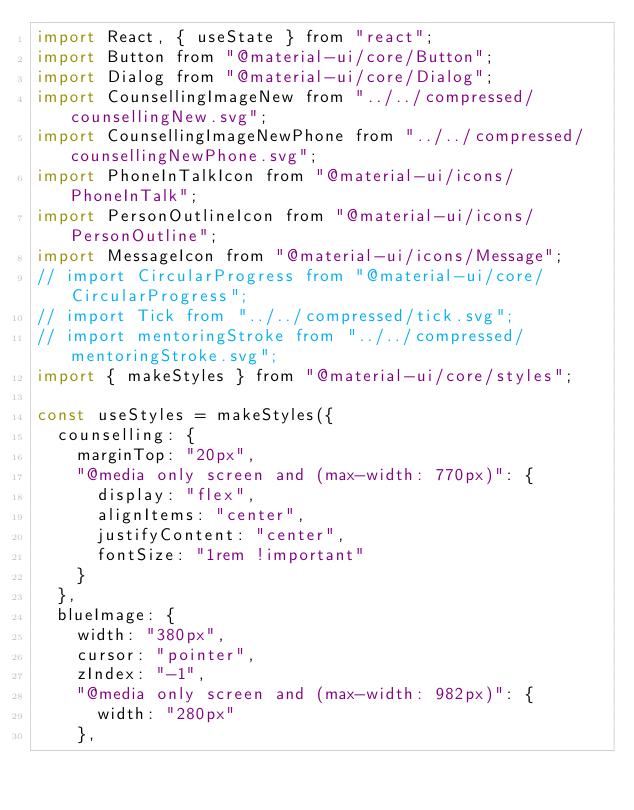Convert code to text. <code><loc_0><loc_0><loc_500><loc_500><_JavaScript_>import React, { useState } from "react";
import Button from "@material-ui/core/Button";
import Dialog from "@material-ui/core/Dialog";
import CounsellingImageNew from "../../compressed/counsellingNew.svg";
import CounsellingImageNewPhone from "../../compressed/counsellingNewPhone.svg";
import PhoneInTalkIcon from "@material-ui/icons/PhoneInTalk";
import PersonOutlineIcon from "@material-ui/icons/PersonOutline";
import MessageIcon from "@material-ui/icons/Message";
// import CircularProgress from "@material-ui/core/CircularProgress";
// import Tick from "../../compressed/tick.svg";
// import mentoringStroke from "../../compressed/mentoringStroke.svg";
import { makeStyles } from "@material-ui/core/styles";

const useStyles = makeStyles({
  counselling: {
    marginTop: "20px",
    "@media only screen and (max-width: 770px)": {
      display: "flex",
      alignItems: "center",
      justifyContent: "center",
      fontSize: "1rem !important"
    }
  },
  blueImage: {
    width: "380px",
    cursor: "pointer",
    zIndex: "-1",
    "@media only screen and (max-width: 982px)": {
      width: "280px"
    },</code> 